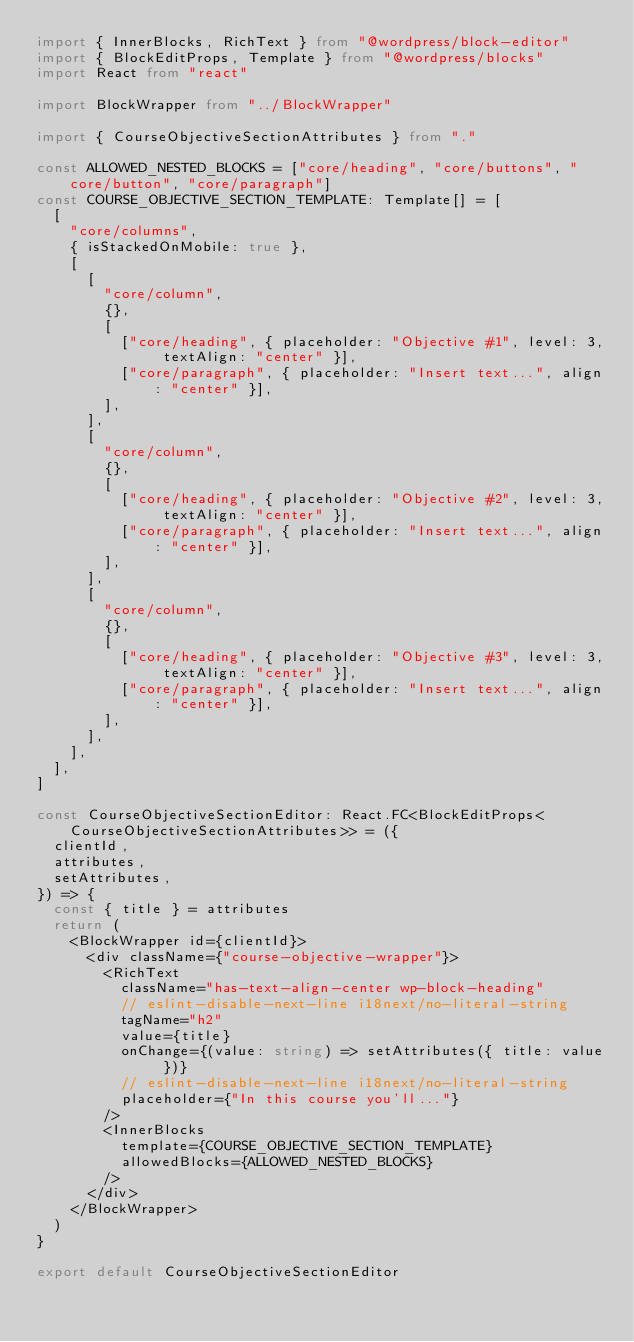<code> <loc_0><loc_0><loc_500><loc_500><_TypeScript_>import { InnerBlocks, RichText } from "@wordpress/block-editor"
import { BlockEditProps, Template } from "@wordpress/blocks"
import React from "react"

import BlockWrapper from "../BlockWrapper"

import { CourseObjectiveSectionAttributes } from "."

const ALLOWED_NESTED_BLOCKS = ["core/heading", "core/buttons", "core/button", "core/paragraph"]
const COURSE_OBJECTIVE_SECTION_TEMPLATE: Template[] = [
  [
    "core/columns",
    { isStackedOnMobile: true },
    [
      [
        "core/column",
        {},
        [
          ["core/heading", { placeholder: "Objective #1", level: 3, textAlign: "center" }],
          ["core/paragraph", { placeholder: "Insert text...", align: "center" }],
        ],
      ],
      [
        "core/column",
        {},
        [
          ["core/heading", { placeholder: "Objective #2", level: 3, textAlign: "center" }],
          ["core/paragraph", { placeholder: "Insert text...", align: "center" }],
        ],
      ],
      [
        "core/column",
        {},
        [
          ["core/heading", { placeholder: "Objective #3", level: 3, textAlign: "center" }],
          ["core/paragraph", { placeholder: "Insert text...", align: "center" }],
        ],
      ],
    ],
  ],
]

const CourseObjectiveSectionEditor: React.FC<BlockEditProps<CourseObjectiveSectionAttributes>> = ({
  clientId,
  attributes,
  setAttributes,
}) => {
  const { title } = attributes
  return (
    <BlockWrapper id={clientId}>
      <div className={"course-objective-wrapper"}>
        <RichText
          className="has-text-align-center wp-block-heading"
          // eslint-disable-next-line i18next/no-literal-string
          tagName="h2"
          value={title}
          onChange={(value: string) => setAttributes({ title: value })}
          // eslint-disable-next-line i18next/no-literal-string
          placeholder={"In this course you'll..."}
        />
        <InnerBlocks
          template={COURSE_OBJECTIVE_SECTION_TEMPLATE}
          allowedBlocks={ALLOWED_NESTED_BLOCKS}
        />
      </div>
    </BlockWrapper>
  )
}

export default CourseObjectiveSectionEditor
</code> 